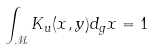<formula> <loc_0><loc_0><loc_500><loc_500>\int _ { \mathcal { M } } K _ { u } ( x , y ) d _ { g } x = 1</formula> 